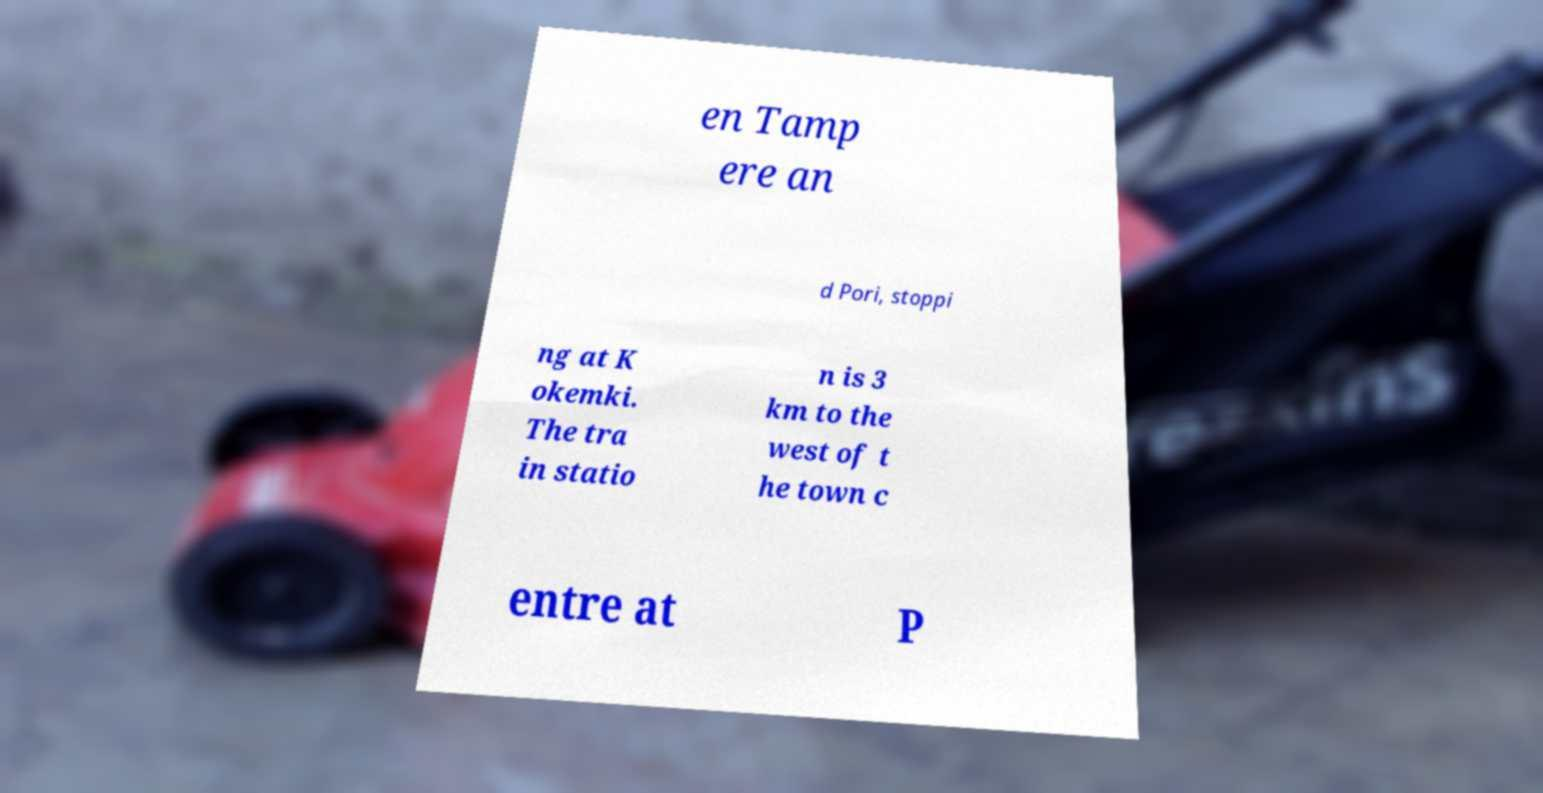Could you assist in decoding the text presented in this image and type it out clearly? en Tamp ere an d Pori, stoppi ng at K okemki. The tra in statio n is 3 km to the west of t he town c entre at P 